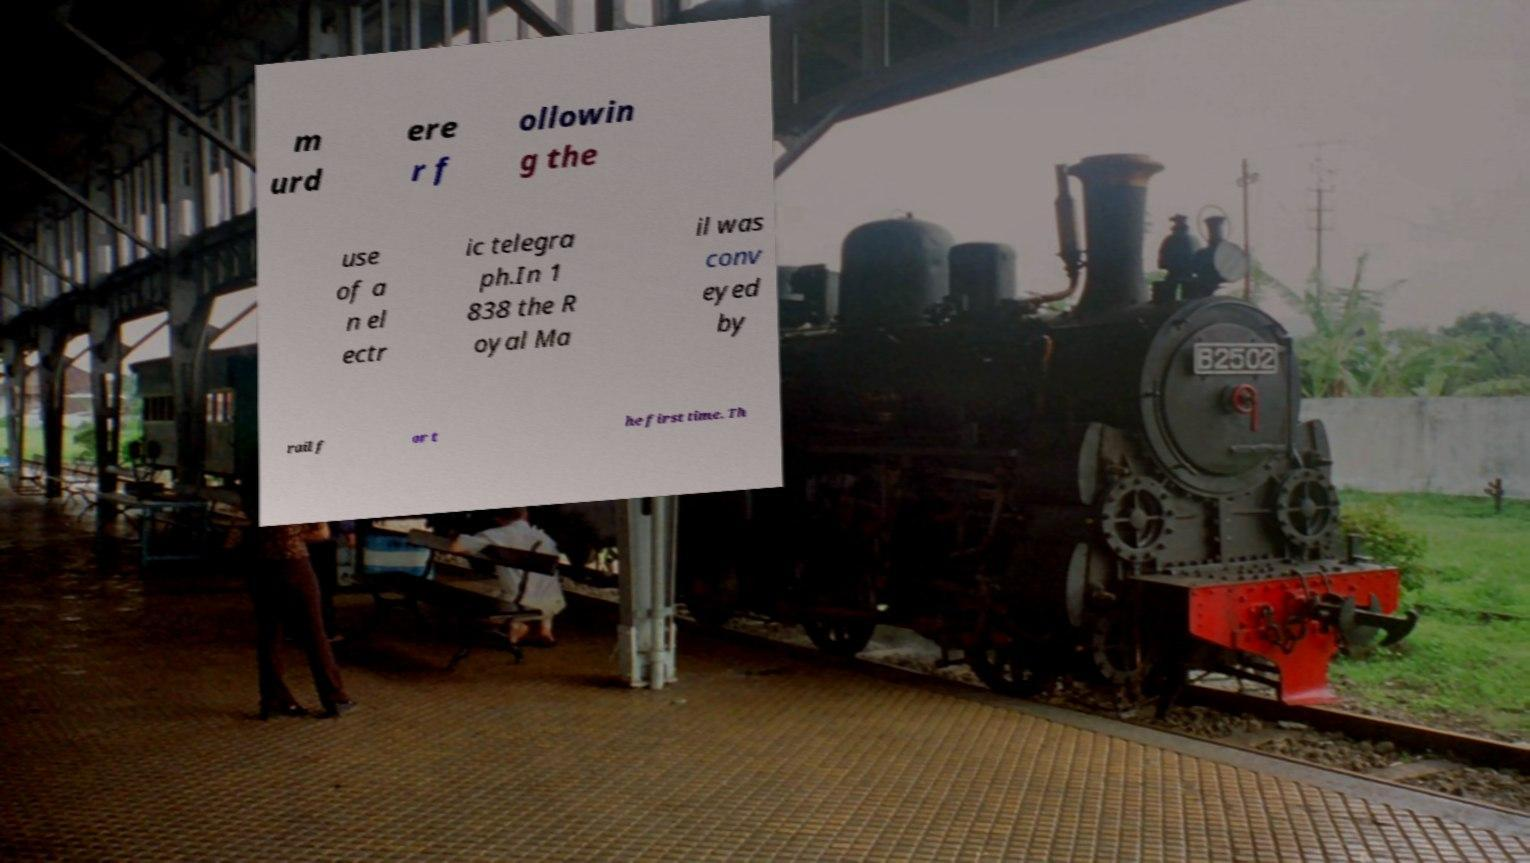For documentation purposes, I need the text within this image transcribed. Could you provide that? m urd ere r f ollowin g the use of a n el ectr ic telegra ph.In 1 838 the R oyal Ma il was conv eyed by rail f or t he first time. Th 